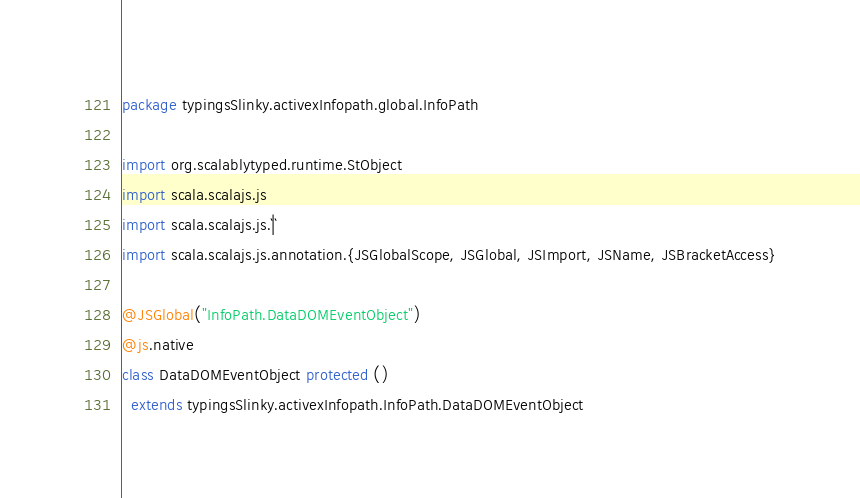<code> <loc_0><loc_0><loc_500><loc_500><_Scala_>package typingsSlinky.activexInfopath.global.InfoPath

import org.scalablytyped.runtime.StObject
import scala.scalajs.js
import scala.scalajs.js.`|`
import scala.scalajs.js.annotation.{JSGlobalScope, JSGlobal, JSImport, JSName, JSBracketAccess}

@JSGlobal("InfoPath.DataDOMEventObject")
@js.native
class DataDOMEventObject protected ()
  extends typingsSlinky.activexInfopath.InfoPath.DataDOMEventObject
</code> 